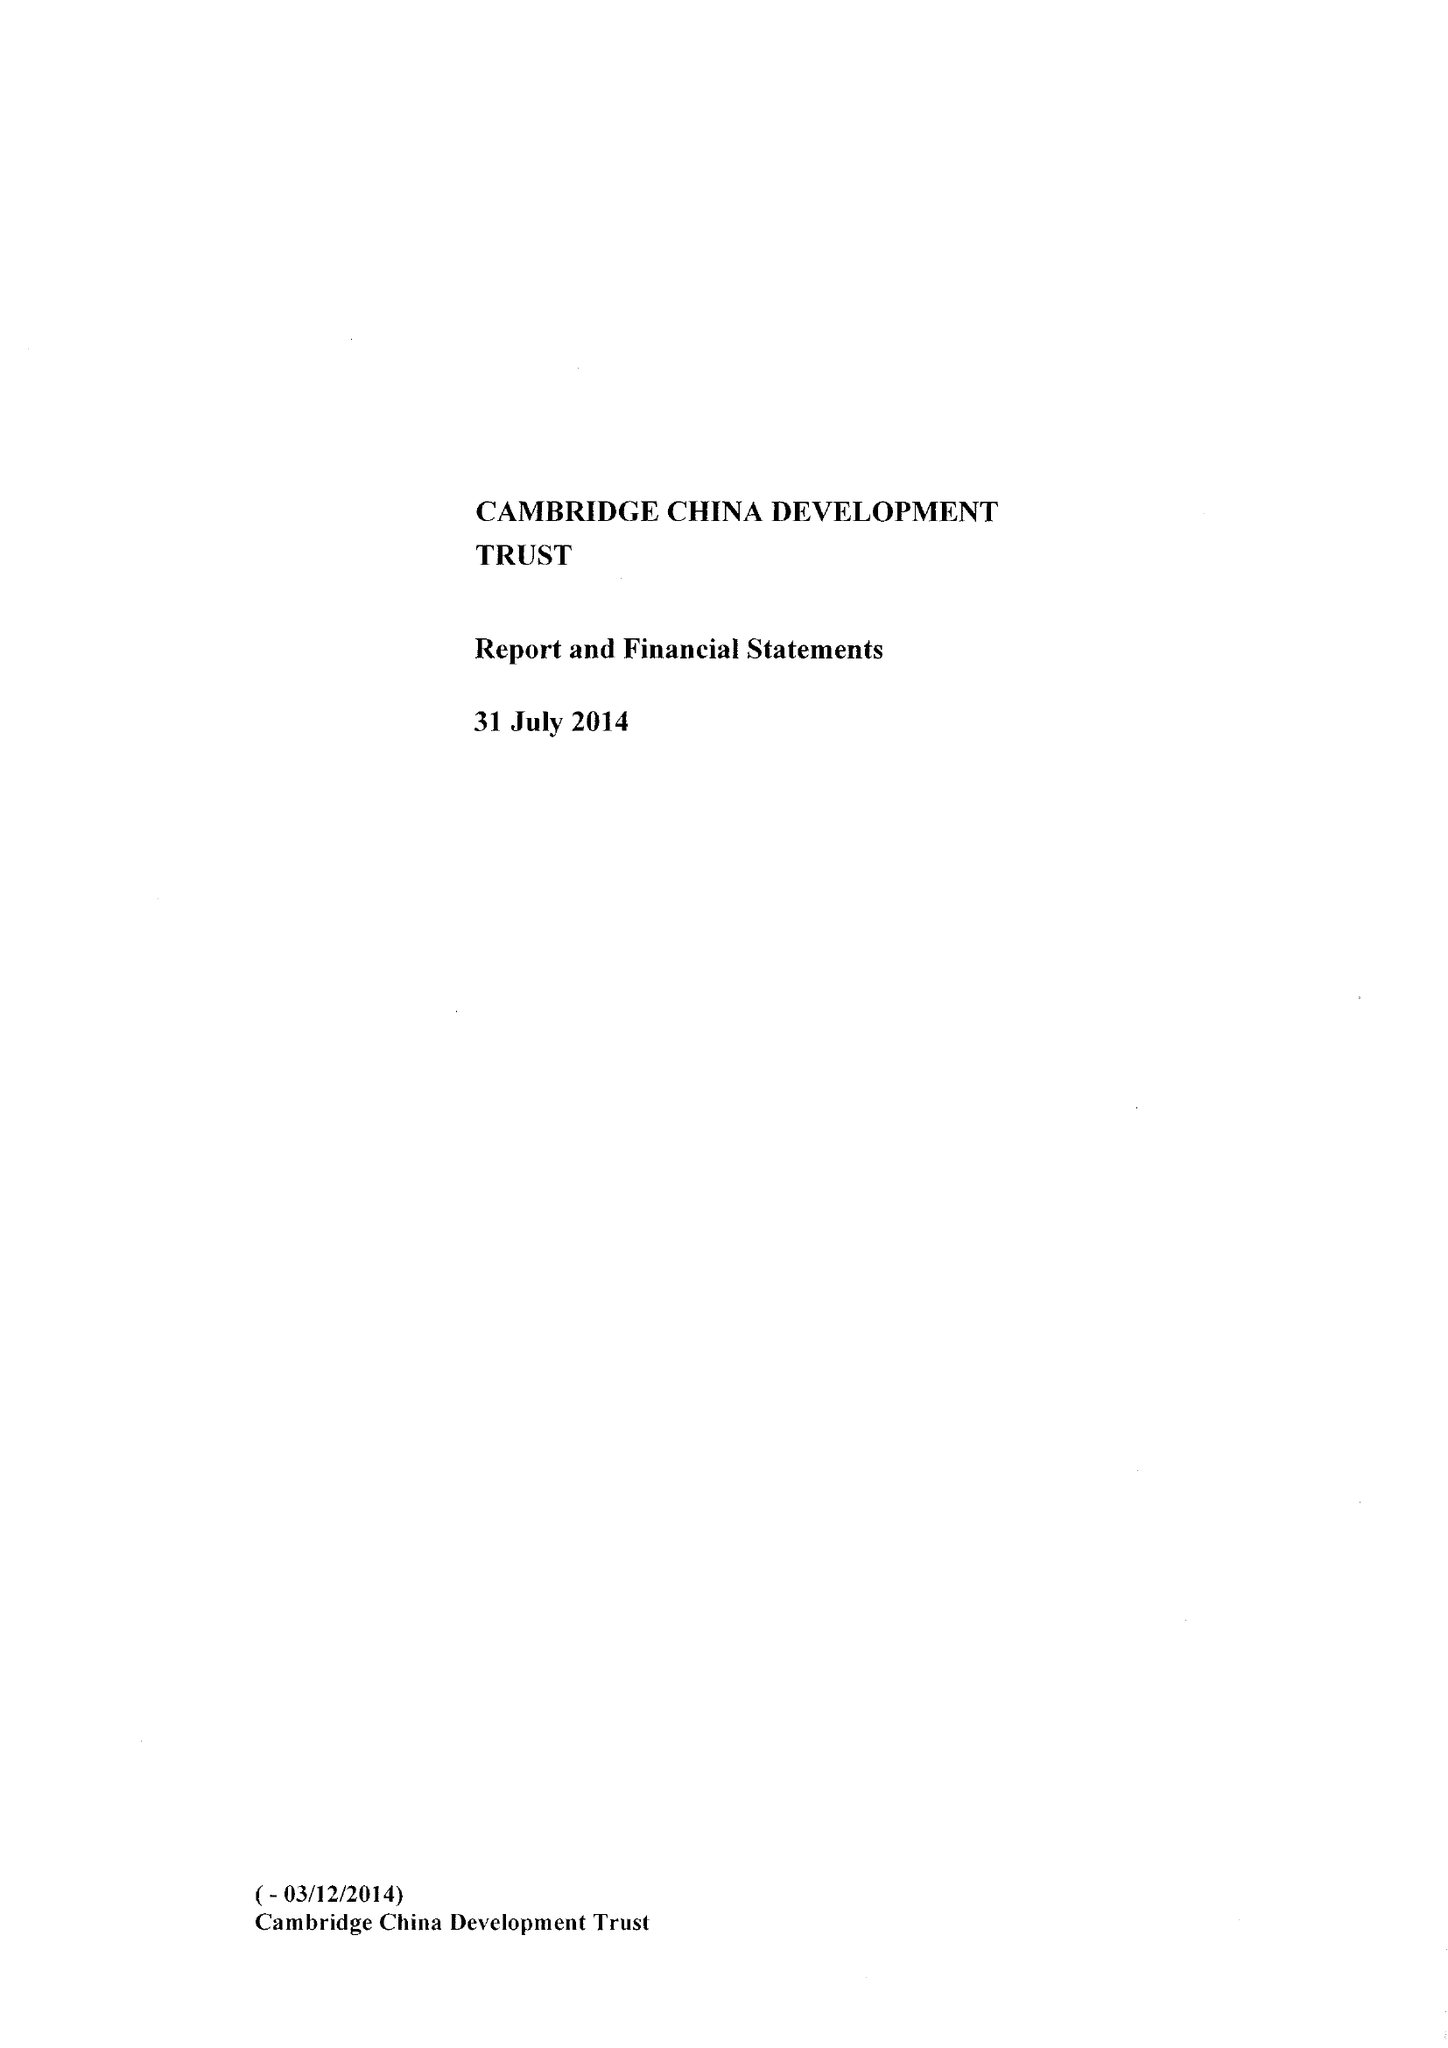What is the value for the address__street_line?
Answer the question using a single word or phrase. None 